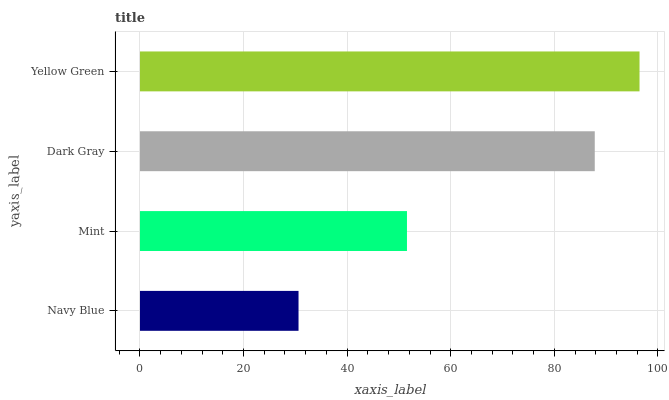Is Navy Blue the minimum?
Answer yes or no. Yes. Is Yellow Green the maximum?
Answer yes or no. Yes. Is Mint the minimum?
Answer yes or no. No. Is Mint the maximum?
Answer yes or no. No. Is Mint greater than Navy Blue?
Answer yes or no. Yes. Is Navy Blue less than Mint?
Answer yes or no. Yes. Is Navy Blue greater than Mint?
Answer yes or no. No. Is Mint less than Navy Blue?
Answer yes or no. No. Is Dark Gray the high median?
Answer yes or no. Yes. Is Mint the low median?
Answer yes or no. Yes. Is Navy Blue the high median?
Answer yes or no. No. Is Navy Blue the low median?
Answer yes or no. No. 